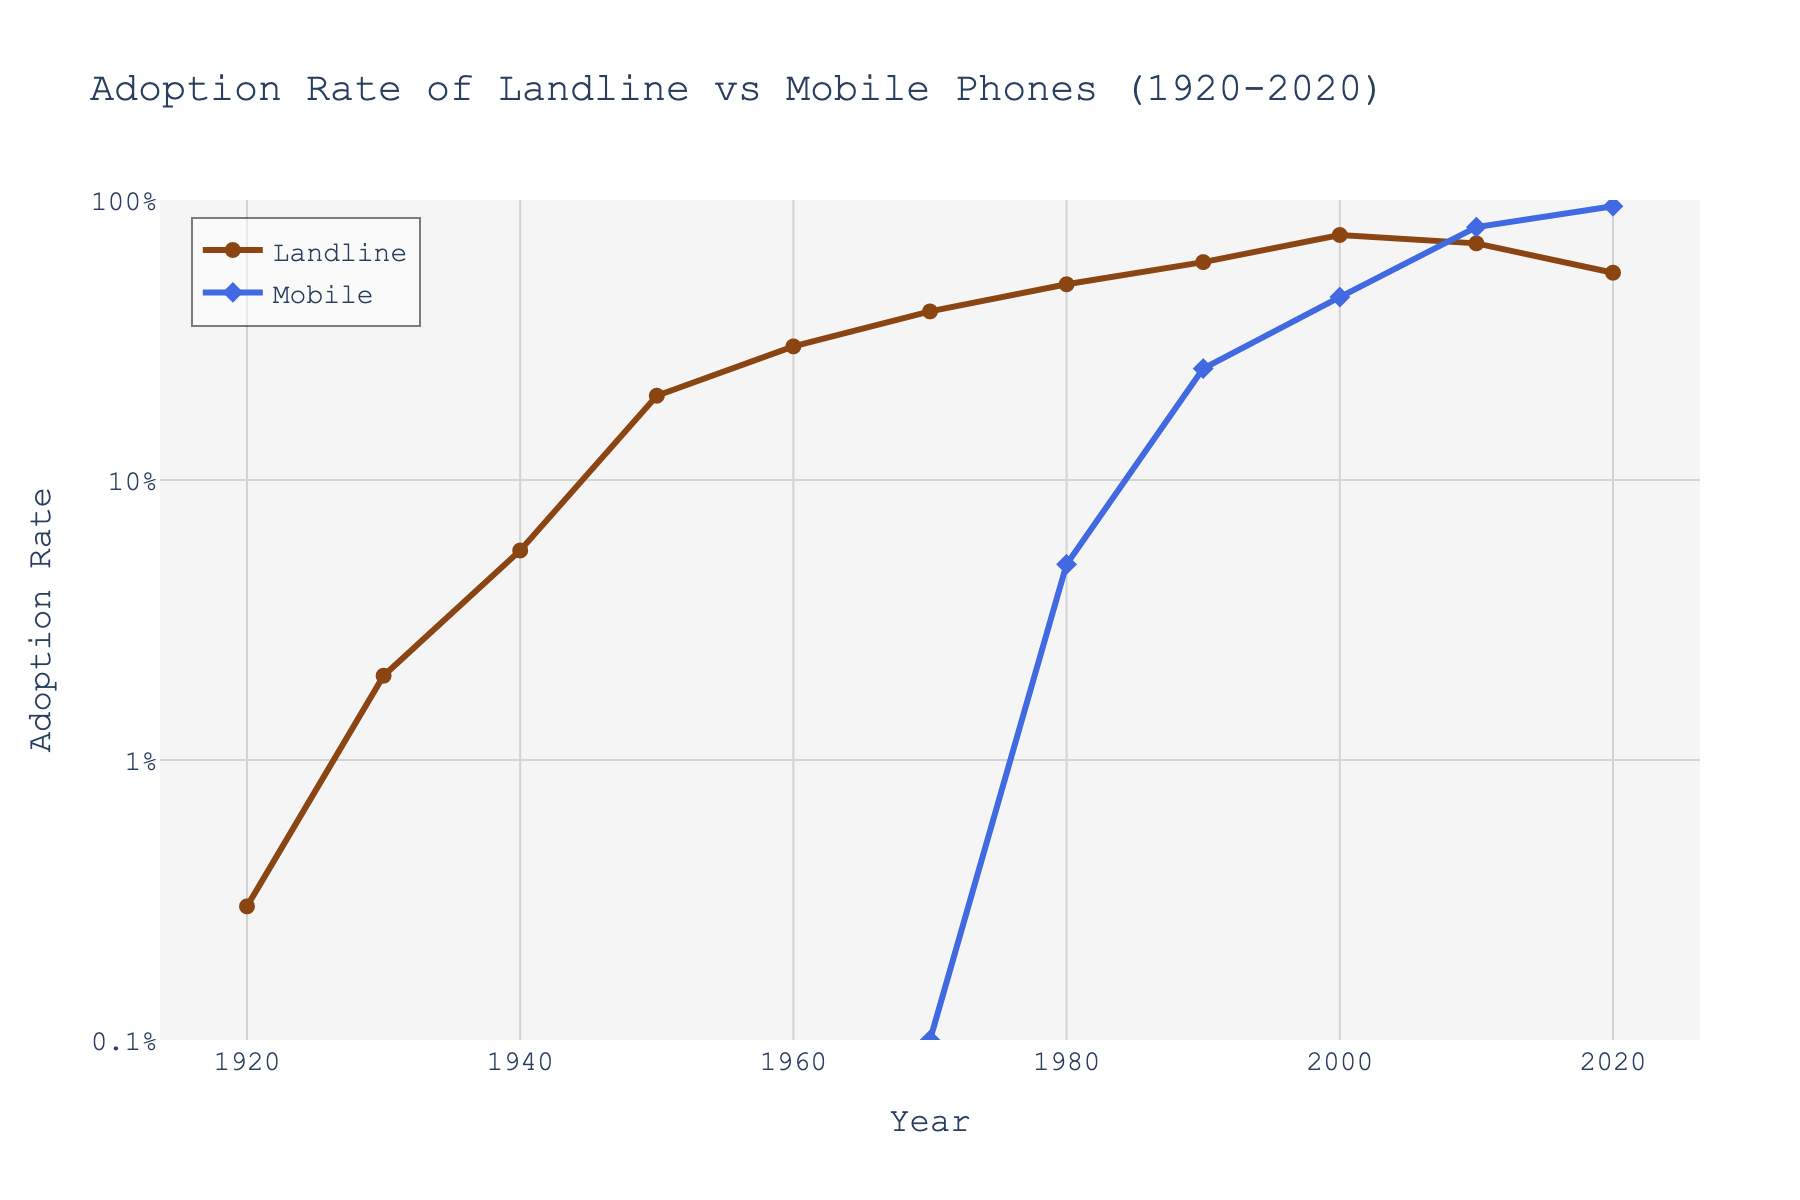What is the title of the figure? The title is usually displayed at the top of the figure and provides a summary of what the figure is about.
Answer: Adoption Rate of Landline vs Mobile Phones (1920-2020) How many data points are plotted for landline adoption rates? Count the number of data points along the 'Landline_Adoption_Rate' line.
Answer: 11 Which year shows the highest adoption rate for mobile phones? Look for the highest point on the 'Mobile' line.
Answer: 2020 In which decade did mobile phone adoption start to rapidly increase? Observe the years where the 'Mobile' line shows a steep upward trend.
Answer: 1990s What is the adoption rate of landline phones in 2000? Find the year 2000 on the x-axis and check the corresponding value on the 'Landline' line.
Answer: 0.75 How do the adoption rates of landline and mobile phones compare in 1980? Check both the 'Landline' and 'Mobile' values in 1980.
Answer: Landline: 0.50, Mobile: 0.05 What is the y-axis scale of the figure? Determine if the y-axis is linear or logarithmic by checking the tick values and labels.
Answer: Logarithmic scale Did the adoption rate of landlines ever surpass 80%? Look at the 'Landline' line to see if it ever reaches or goes above the 80% mark.
Answer: No What was the approximate adoption rate of landline phones in 1920 compared to mobile phones in 2020? Compare the 'Landline' value in 1920 to the 'Mobile' value in 2020.
Answer: Landline 1920: 0.003, Mobile 2020: 0.95 During which period did the adoption rate of landlines start to decline? Identify the point at which the 'Landline' line starts to go downward.
Answer: After 2000 